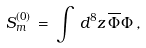Convert formula to latex. <formula><loc_0><loc_0><loc_500><loc_500>S _ { m } ^ { ( 0 ) } \, = \, \int \, d ^ { 8 } z \, \overline { \Phi } { \Phi } \, ,</formula> 